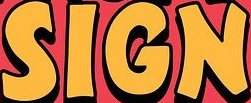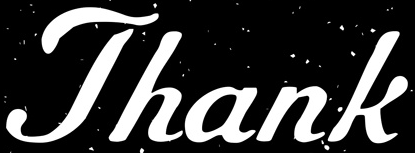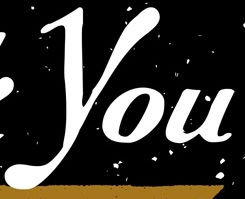What words are shown in these images in order, separated by a semicolon? SIGN; Thank; You 